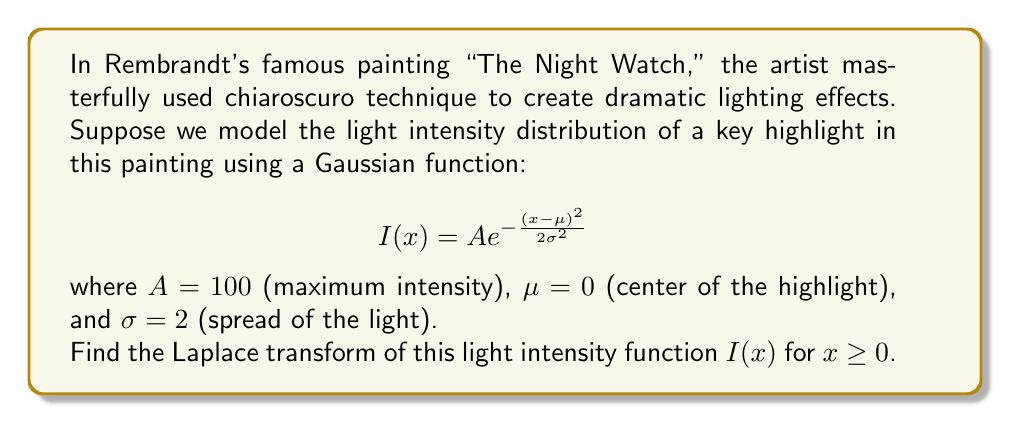Give your solution to this math problem. To solve this problem, we'll follow these steps:

1) The Laplace transform of a function $f(x)$ is defined as:

   $$\mathcal{L}\{f(x)\} = F(s) = \int_0^\infty e^{-sx} f(x) dx$$

2) In our case, $f(x) = I(x) = 100 e^{-\frac{x^2}{8}}$ for $x \geq 0$ (since $\mu = 0$ and $\sigma = 2$)

3) Substituting this into the Laplace transform formula:

   $$\mathcal{L}\{I(x)\} = \int_0^\infty e^{-sx} \cdot 100 e^{-\frac{x^2}{8}} dx$$

4) Simplifying:

   $$\mathcal{L}\{I(x)\} = 100 \int_0^\infty e^{-sx-\frac{x^2}{8}} dx$$

5) This integral is in the form of a Gaussian integral. We can complete the square in the exponent:

   $$-sx-\frac{x^2}{8} = -\frac{1}{8}(x^2 + 8sx) = -\frac{1}{8}((x+4s)^2 - 16s^2)$$

6) Substituting this back:

   $$\mathcal{L}\{I(x)\} = 100 e^{2s^2} \int_0^\infty e^{-\frac{(x+4s)^2}{8}} dx$$

7) Now, we can use the properties of the error function. The integral of a Gaussian function from $-\infty$ to $\infty$ is known:

   $$\int_{-\infty}^{\infty} e^{-\frac{x^2}{2a^2}} dx = a\sqrt{2\pi}$$

8) In our case, $a = 2$, so:

   $$\mathcal{L}\{I(x)\} = 100 e^{2s^2} \cdot 2\sqrt{2\pi} \cdot \frac{1}{2} \text{erfc}(2s)$$

9) Simplifying:

   $$\mathcal{L}\{I(x)\} = 100\sqrt{2\pi} e^{2s^2} \text{erfc}(2s)$$

Where erfc is the complementary error function.
Answer: $$\mathcal{L}\{I(x)\} = 100\sqrt{2\pi} e^{2s^2} \text{erfc}(2s)$$ 